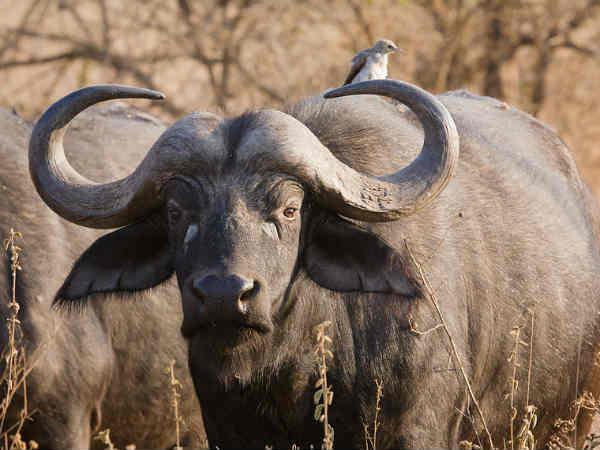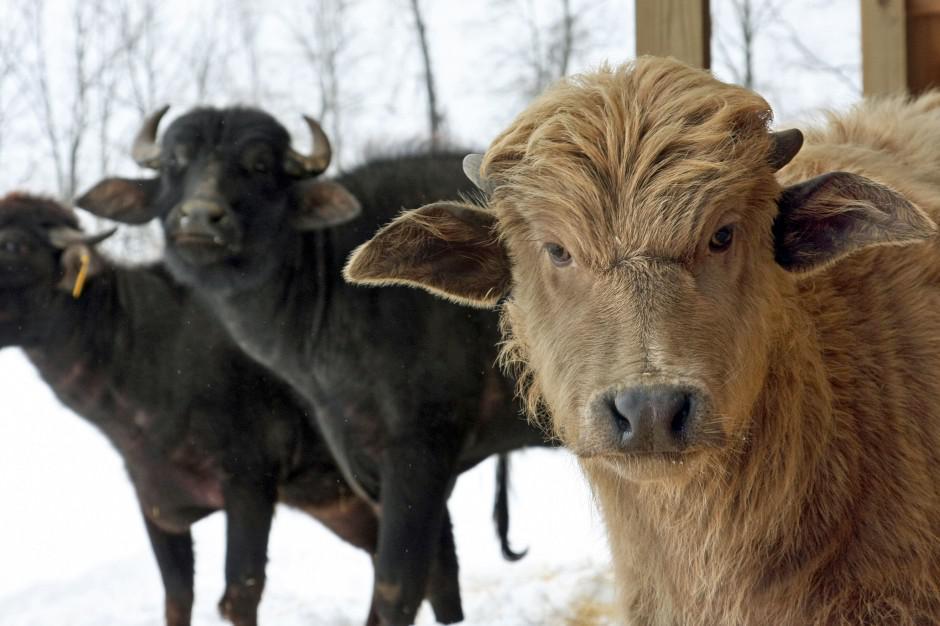The first image is the image on the left, the second image is the image on the right. Examine the images to the left and right. Is the description "In each image, there is at least one cow looking directly at the camera." accurate? Answer yes or no. Yes. The first image is the image on the left, the second image is the image on the right. For the images displayed, is the sentence "Each image includes a water buffalo with its face mostly forward." factually correct? Answer yes or no. Yes. 